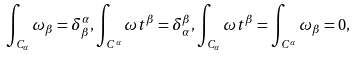Convert formula to latex. <formula><loc_0><loc_0><loc_500><loc_500>\int _ { C _ { \alpha } } \omega _ { \beta } = \delta ^ { \alpha } _ { \beta } , \int _ { C ^ { \alpha } } \omega t ^ { \beta } = \delta ^ { \beta } _ { \alpha } , \int _ { C _ { \alpha } } \omega t ^ { \beta } = \int _ { C ^ { \alpha } } \omega _ { \beta } = 0 ,</formula> 